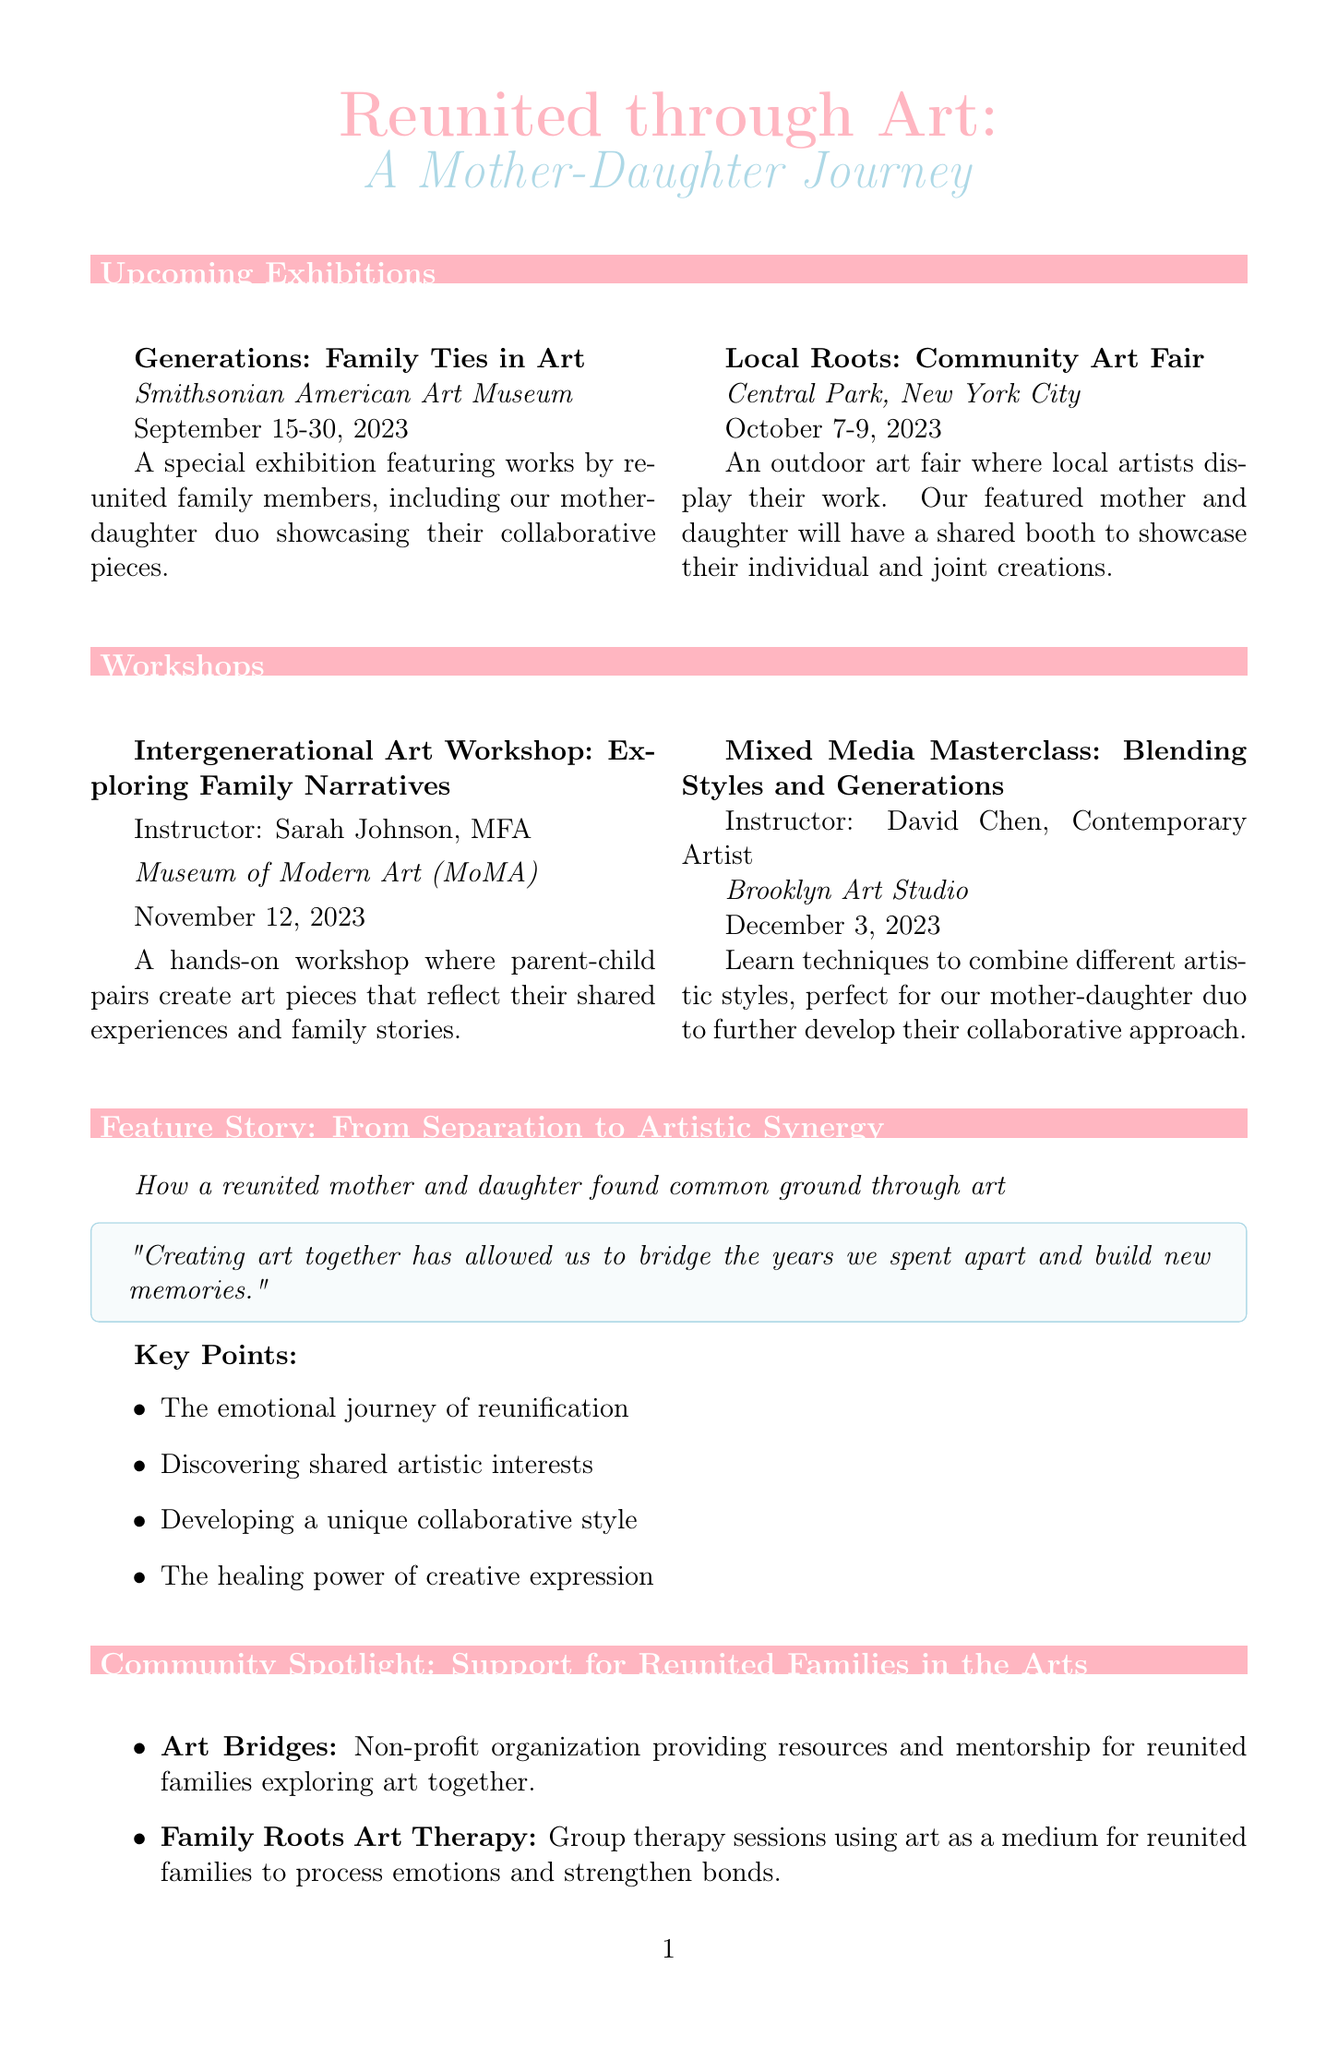What is the title of the newsletter? The title is prominently displayed at the top of the document.
Answer: Reunited through Art: A Mother-Daughter Journey When does the exhibition "Generations: Family Ties in Art" take place? The dates are listed under the exhibition section.
Answer: September 15-30, 2023 What workshop takes place on December 3, 2023? The workshops section provides the specific date and name of the workshop.
Answer: Mixed Media Masterclass: Blending Styles and Generations Who is the instructor for the "Intergenerational Art Workshop"? The instructor's name is mentioned alongside the workshop details.
Answer: Sarah Johnson, MFA Where will the "Local Roots: Community Art Fair" be held? The venue is specified in the description of the exhibition.
Answer: Central Park, New York City What is one key point from the feature story? The key points are listed in bullet format under the feature story section.
Answer: The emotional journey of reunification What organization offers mentorship for reunited families? The organizations are described in the community spotlight section.
Answer: Art Bridges What type of art session does Family Roots Art Therapy provide? The description specifies the purpose of the sessions in the community spotlight section.
Answer: Group therapy sessions What colors represent the mother and daughter themes in the newsletter? The colors are specified in the document and associated with different sections.
Answer: Motherpink and Daughterblue 